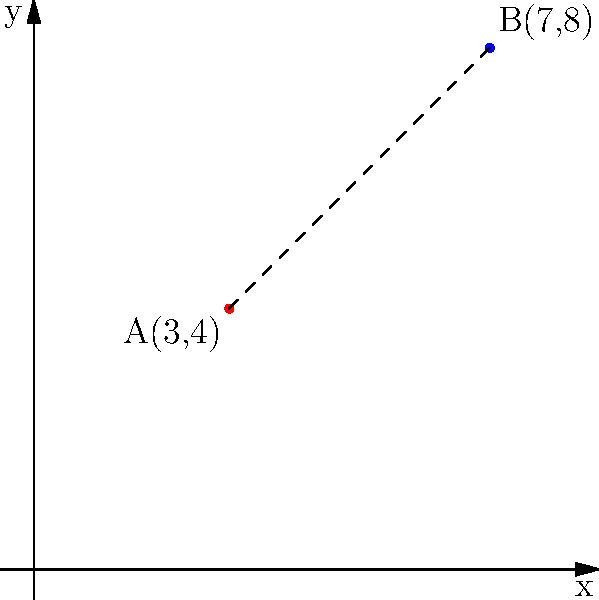Given two points A(3,4) and B(7,8) on a coordinate plane, calculate the exact distance between them using the distance formula. To find the distance between two points, we use the distance formula:

$d = \sqrt{(x_2 - x_1)^2 + (y_2 - y_1)^2}$

Where $(x_1, y_1)$ are the coordinates of point A and $(x_2, y_2)$ are the coordinates of point B.

Step 1: Identify the coordinates
A(3,4): $x_1 = 3$, $y_1 = 4$
B(7,8): $x_2 = 7$, $y_2 = 8$

Step 2: Plug the values into the formula
$d = \sqrt{(7 - 3)^2 + (8 - 4)^2}$

Step 3: Simplify inside the parentheses
$d = \sqrt{4^2 + 4^2}$

Step 4: Calculate the squares
$d = \sqrt{16 + 16}$

Step 5: Add under the square root
$d = \sqrt{32}$

Step 6: Simplify the square root
$d = 4\sqrt{2}$
Answer: $4\sqrt{2}$ 